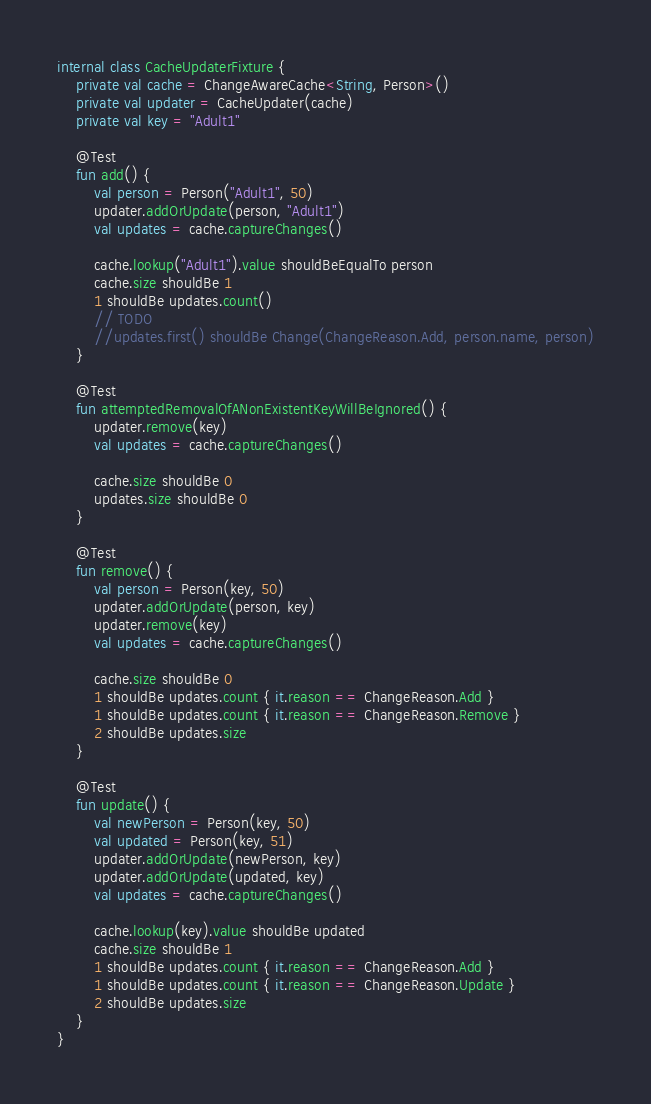<code> <loc_0><loc_0><loc_500><loc_500><_Kotlin_>internal class CacheUpdaterFixture {
    private val cache = ChangeAwareCache<String, Person>()
    private val updater = CacheUpdater(cache)
    private val key = "Adult1"

    @Test
    fun add() {
        val person = Person("Adult1", 50)
        updater.addOrUpdate(person, "Adult1")
        val updates = cache.captureChanges()

        cache.lookup("Adult1").value shouldBeEqualTo person
        cache.size shouldBe 1
        1 shouldBe updates.count()
        // TODO
        //updates.first() shouldBe Change(ChangeReason.Add, person.name, person)
    }

    @Test
    fun attemptedRemovalOfANonExistentKeyWillBeIgnored() {
        updater.remove(key)
        val updates = cache.captureChanges()

        cache.size shouldBe 0
        updates.size shouldBe 0
    }

    @Test
    fun remove() {
        val person = Person(key, 50)
        updater.addOrUpdate(person, key)
        updater.remove(key)
        val updates = cache.captureChanges()

        cache.size shouldBe 0
        1 shouldBe updates.count { it.reason == ChangeReason.Add }
        1 shouldBe updates.count { it.reason == ChangeReason.Remove }
        2 shouldBe updates.size
    }

    @Test
    fun update() {
        val newPerson = Person(key, 50)
        val updated = Person(key, 51)
        updater.addOrUpdate(newPerson, key)
        updater.addOrUpdate(updated, key)
        val updates = cache.captureChanges()

        cache.lookup(key).value shouldBe updated
        cache.size shouldBe 1
        1 shouldBe updates.count { it.reason == ChangeReason.Add }
        1 shouldBe updates.count { it.reason == ChangeReason.Update }
        2 shouldBe updates.size
    }
}
</code> 